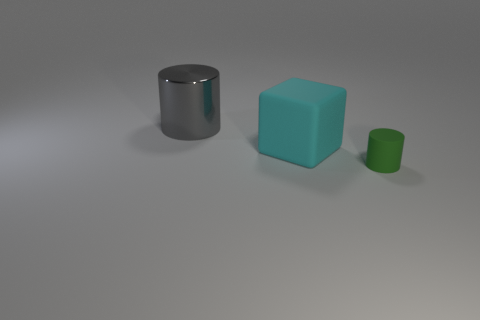Add 1 large gray objects. How many objects exist? 4 Subtract all cubes. How many objects are left? 2 Subtract all blue blocks. Subtract all big things. How many objects are left? 1 Add 1 large blocks. How many large blocks are left? 2 Add 3 big cubes. How many big cubes exist? 4 Subtract 0 red cylinders. How many objects are left? 3 